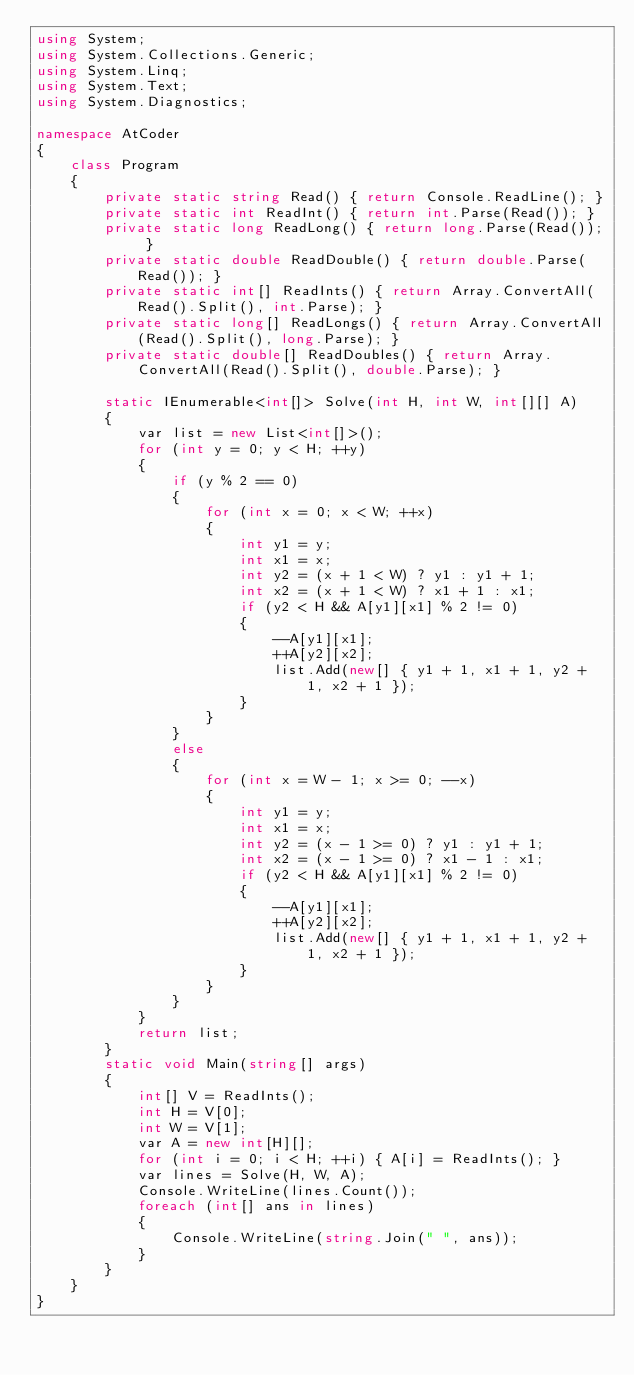Convert code to text. <code><loc_0><loc_0><loc_500><loc_500><_C#_>using System;
using System.Collections.Generic;
using System.Linq;
using System.Text;
using System.Diagnostics;

namespace AtCoder
{
    class Program
    {
        private static string Read() { return Console.ReadLine(); }
        private static int ReadInt() { return int.Parse(Read()); }
        private static long ReadLong() { return long.Parse(Read()); }
        private static double ReadDouble() { return double.Parse(Read()); }
        private static int[] ReadInts() { return Array.ConvertAll(Read().Split(), int.Parse); }
        private static long[] ReadLongs() { return Array.ConvertAll(Read().Split(), long.Parse); }
        private static double[] ReadDoubles() { return Array.ConvertAll(Read().Split(), double.Parse); }

        static IEnumerable<int[]> Solve(int H, int W, int[][] A)
        {
            var list = new List<int[]>();
            for (int y = 0; y < H; ++y)
            {
                if (y % 2 == 0)
                {
                    for (int x = 0; x < W; ++x)
                    {
                        int y1 = y;
                        int x1 = x;
                        int y2 = (x + 1 < W) ? y1 : y1 + 1;
                        int x2 = (x + 1 < W) ? x1 + 1 : x1;
                        if (y2 < H && A[y1][x1] % 2 != 0)
                        {
                            --A[y1][x1];
                            ++A[y2][x2];
                            list.Add(new[] { y1 + 1, x1 + 1, y2 + 1, x2 + 1 });
                        }
                    }
                }
                else
                {
                    for (int x = W - 1; x >= 0; --x)
                    {
                        int y1 = y;
                        int x1 = x;
                        int y2 = (x - 1 >= 0) ? y1 : y1 + 1;
                        int x2 = (x - 1 >= 0) ? x1 - 1 : x1;
                        if (y2 < H && A[y1][x1] % 2 != 0)
                        {
                            --A[y1][x1];
                            ++A[y2][x2];
                            list.Add(new[] { y1 + 1, x1 + 1, y2 + 1, x2 + 1 });
                        }
                    }
                }
            }
            return list;
        }
        static void Main(string[] args)
        {
            int[] V = ReadInts();
            int H = V[0];
            int W = V[1];
            var A = new int[H][];
            for (int i = 0; i < H; ++i) { A[i] = ReadInts(); }
            var lines = Solve(H, W, A);
            Console.WriteLine(lines.Count());
            foreach (int[] ans in lines)
            {
                Console.WriteLine(string.Join(" ", ans));
            }
        }
    }
}
</code> 